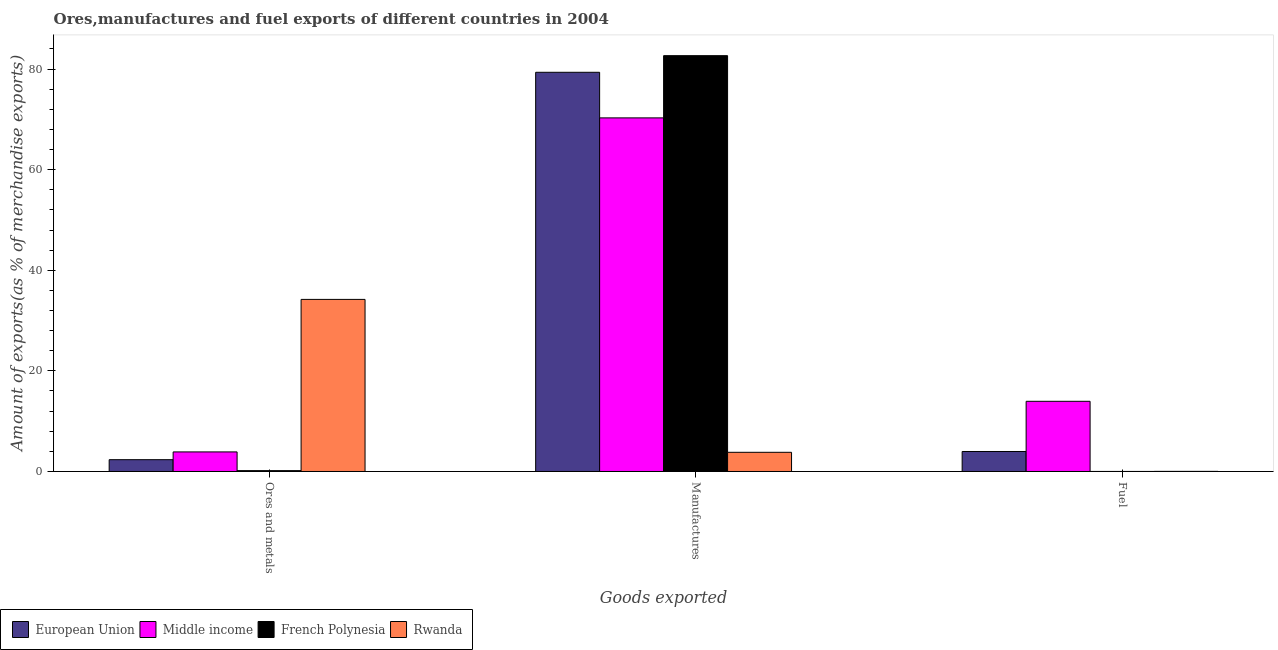How many different coloured bars are there?
Make the answer very short. 4. Are the number of bars per tick equal to the number of legend labels?
Provide a succinct answer. Yes. Are the number of bars on each tick of the X-axis equal?
Provide a succinct answer. Yes. How many bars are there on the 1st tick from the left?
Offer a very short reply. 4. How many bars are there on the 1st tick from the right?
Your answer should be compact. 4. What is the label of the 2nd group of bars from the left?
Offer a terse response. Manufactures. What is the percentage of ores and metals exports in European Union?
Your answer should be very brief. 2.35. Across all countries, what is the maximum percentage of ores and metals exports?
Give a very brief answer. 34.21. Across all countries, what is the minimum percentage of fuel exports?
Provide a short and direct response. 0. In which country was the percentage of manufactures exports maximum?
Provide a succinct answer. French Polynesia. In which country was the percentage of manufactures exports minimum?
Keep it short and to the point. Rwanda. What is the total percentage of fuel exports in the graph?
Provide a succinct answer. 17.95. What is the difference between the percentage of fuel exports in Rwanda and that in European Union?
Offer a terse response. -3.95. What is the difference between the percentage of fuel exports in Middle income and the percentage of manufactures exports in Rwanda?
Give a very brief answer. 10.14. What is the average percentage of manufactures exports per country?
Ensure brevity in your answer.  59.03. What is the difference between the percentage of manufactures exports and percentage of ores and metals exports in Rwanda?
Provide a succinct answer. -30.39. What is the ratio of the percentage of ores and metals exports in Rwanda to that in Middle income?
Provide a succinct answer. 8.8. Is the percentage of fuel exports in European Union less than that in Middle income?
Your answer should be very brief. Yes. Is the difference between the percentage of manufactures exports in Middle income and European Union greater than the difference between the percentage of ores and metals exports in Middle income and European Union?
Your answer should be compact. No. What is the difference between the highest and the second highest percentage of manufactures exports?
Your response must be concise. 3.31. What is the difference between the highest and the lowest percentage of manufactures exports?
Your response must be concise. 78.84. What does the 3rd bar from the right in Fuel represents?
Your response must be concise. Middle income. Is it the case that in every country, the sum of the percentage of ores and metals exports and percentage of manufactures exports is greater than the percentage of fuel exports?
Your response must be concise. Yes. How many bars are there?
Your answer should be compact. 12. What is the difference between two consecutive major ticks on the Y-axis?
Provide a succinct answer. 20. Are the values on the major ticks of Y-axis written in scientific E-notation?
Your answer should be very brief. No. Does the graph contain any zero values?
Offer a terse response. No. Does the graph contain grids?
Ensure brevity in your answer.  No. What is the title of the graph?
Ensure brevity in your answer.  Ores,manufactures and fuel exports of different countries in 2004. Does "Belgium" appear as one of the legend labels in the graph?
Give a very brief answer. No. What is the label or title of the X-axis?
Provide a succinct answer. Goods exported. What is the label or title of the Y-axis?
Keep it short and to the point. Amount of exports(as % of merchandise exports). What is the Amount of exports(as % of merchandise exports) of European Union in Ores and metals?
Provide a succinct answer. 2.35. What is the Amount of exports(as % of merchandise exports) of Middle income in Ores and metals?
Keep it short and to the point. 3.89. What is the Amount of exports(as % of merchandise exports) in French Polynesia in Ores and metals?
Provide a short and direct response. 0.17. What is the Amount of exports(as % of merchandise exports) in Rwanda in Ores and metals?
Provide a succinct answer. 34.21. What is the Amount of exports(as % of merchandise exports) in European Union in Manufactures?
Make the answer very short. 79.35. What is the Amount of exports(as % of merchandise exports) of Middle income in Manufactures?
Provide a short and direct response. 70.29. What is the Amount of exports(as % of merchandise exports) in French Polynesia in Manufactures?
Your response must be concise. 82.66. What is the Amount of exports(as % of merchandise exports) in Rwanda in Manufactures?
Provide a succinct answer. 3.81. What is the Amount of exports(as % of merchandise exports) of European Union in Fuel?
Your response must be concise. 3.97. What is the Amount of exports(as % of merchandise exports) in Middle income in Fuel?
Give a very brief answer. 13.95. What is the Amount of exports(as % of merchandise exports) in French Polynesia in Fuel?
Your answer should be compact. 0. What is the Amount of exports(as % of merchandise exports) in Rwanda in Fuel?
Offer a very short reply. 0.02. Across all Goods exported, what is the maximum Amount of exports(as % of merchandise exports) of European Union?
Keep it short and to the point. 79.35. Across all Goods exported, what is the maximum Amount of exports(as % of merchandise exports) in Middle income?
Provide a short and direct response. 70.29. Across all Goods exported, what is the maximum Amount of exports(as % of merchandise exports) of French Polynesia?
Your response must be concise. 82.66. Across all Goods exported, what is the maximum Amount of exports(as % of merchandise exports) in Rwanda?
Ensure brevity in your answer.  34.21. Across all Goods exported, what is the minimum Amount of exports(as % of merchandise exports) of European Union?
Your response must be concise. 2.35. Across all Goods exported, what is the minimum Amount of exports(as % of merchandise exports) of Middle income?
Your response must be concise. 3.89. Across all Goods exported, what is the minimum Amount of exports(as % of merchandise exports) in French Polynesia?
Keep it short and to the point. 0. Across all Goods exported, what is the minimum Amount of exports(as % of merchandise exports) of Rwanda?
Offer a terse response. 0.02. What is the total Amount of exports(as % of merchandise exports) of European Union in the graph?
Give a very brief answer. 85.67. What is the total Amount of exports(as % of merchandise exports) of Middle income in the graph?
Keep it short and to the point. 88.13. What is the total Amount of exports(as % of merchandise exports) in French Polynesia in the graph?
Offer a very short reply. 82.83. What is the total Amount of exports(as % of merchandise exports) in Rwanda in the graph?
Offer a terse response. 38.04. What is the difference between the Amount of exports(as % of merchandise exports) of European Union in Ores and metals and that in Manufactures?
Give a very brief answer. -77. What is the difference between the Amount of exports(as % of merchandise exports) of Middle income in Ores and metals and that in Manufactures?
Your response must be concise. -66.4. What is the difference between the Amount of exports(as % of merchandise exports) of French Polynesia in Ores and metals and that in Manufactures?
Your answer should be very brief. -82.49. What is the difference between the Amount of exports(as % of merchandise exports) of Rwanda in Ores and metals and that in Manufactures?
Offer a terse response. 30.39. What is the difference between the Amount of exports(as % of merchandise exports) of European Union in Ores and metals and that in Fuel?
Keep it short and to the point. -1.63. What is the difference between the Amount of exports(as % of merchandise exports) of Middle income in Ores and metals and that in Fuel?
Make the answer very short. -10.06. What is the difference between the Amount of exports(as % of merchandise exports) of French Polynesia in Ores and metals and that in Fuel?
Keep it short and to the point. 0.16. What is the difference between the Amount of exports(as % of merchandise exports) in Rwanda in Ores and metals and that in Fuel?
Provide a succinct answer. 34.18. What is the difference between the Amount of exports(as % of merchandise exports) in European Union in Manufactures and that in Fuel?
Your response must be concise. 75.38. What is the difference between the Amount of exports(as % of merchandise exports) in Middle income in Manufactures and that in Fuel?
Offer a terse response. 56.34. What is the difference between the Amount of exports(as % of merchandise exports) in French Polynesia in Manufactures and that in Fuel?
Provide a succinct answer. 82.65. What is the difference between the Amount of exports(as % of merchandise exports) of Rwanda in Manufactures and that in Fuel?
Your answer should be compact. 3.79. What is the difference between the Amount of exports(as % of merchandise exports) in European Union in Ores and metals and the Amount of exports(as % of merchandise exports) in Middle income in Manufactures?
Your answer should be very brief. -67.94. What is the difference between the Amount of exports(as % of merchandise exports) of European Union in Ores and metals and the Amount of exports(as % of merchandise exports) of French Polynesia in Manufactures?
Offer a very short reply. -80.31. What is the difference between the Amount of exports(as % of merchandise exports) of European Union in Ores and metals and the Amount of exports(as % of merchandise exports) of Rwanda in Manufactures?
Your answer should be compact. -1.47. What is the difference between the Amount of exports(as % of merchandise exports) in Middle income in Ores and metals and the Amount of exports(as % of merchandise exports) in French Polynesia in Manufactures?
Offer a terse response. -78.77. What is the difference between the Amount of exports(as % of merchandise exports) in Middle income in Ores and metals and the Amount of exports(as % of merchandise exports) in Rwanda in Manufactures?
Your answer should be very brief. 0.08. What is the difference between the Amount of exports(as % of merchandise exports) of French Polynesia in Ores and metals and the Amount of exports(as % of merchandise exports) of Rwanda in Manufactures?
Make the answer very short. -3.65. What is the difference between the Amount of exports(as % of merchandise exports) of European Union in Ores and metals and the Amount of exports(as % of merchandise exports) of Middle income in Fuel?
Your response must be concise. -11.6. What is the difference between the Amount of exports(as % of merchandise exports) of European Union in Ores and metals and the Amount of exports(as % of merchandise exports) of French Polynesia in Fuel?
Offer a terse response. 2.34. What is the difference between the Amount of exports(as % of merchandise exports) in European Union in Ores and metals and the Amount of exports(as % of merchandise exports) in Rwanda in Fuel?
Provide a short and direct response. 2.33. What is the difference between the Amount of exports(as % of merchandise exports) of Middle income in Ores and metals and the Amount of exports(as % of merchandise exports) of French Polynesia in Fuel?
Provide a short and direct response. 3.89. What is the difference between the Amount of exports(as % of merchandise exports) in Middle income in Ores and metals and the Amount of exports(as % of merchandise exports) in Rwanda in Fuel?
Provide a short and direct response. 3.87. What is the difference between the Amount of exports(as % of merchandise exports) in French Polynesia in Ores and metals and the Amount of exports(as % of merchandise exports) in Rwanda in Fuel?
Provide a short and direct response. 0.15. What is the difference between the Amount of exports(as % of merchandise exports) in European Union in Manufactures and the Amount of exports(as % of merchandise exports) in Middle income in Fuel?
Make the answer very short. 65.4. What is the difference between the Amount of exports(as % of merchandise exports) of European Union in Manufactures and the Amount of exports(as % of merchandise exports) of French Polynesia in Fuel?
Provide a succinct answer. 79.35. What is the difference between the Amount of exports(as % of merchandise exports) of European Union in Manufactures and the Amount of exports(as % of merchandise exports) of Rwanda in Fuel?
Make the answer very short. 79.33. What is the difference between the Amount of exports(as % of merchandise exports) in Middle income in Manufactures and the Amount of exports(as % of merchandise exports) in French Polynesia in Fuel?
Offer a terse response. 70.28. What is the difference between the Amount of exports(as % of merchandise exports) in Middle income in Manufactures and the Amount of exports(as % of merchandise exports) in Rwanda in Fuel?
Ensure brevity in your answer.  70.27. What is the difference between the Amount of exports(as % of merchandise exports) in French Polynesia in Manufactures and the Amount of exports(as % of merchandise exports) in Rwanda in Fuel?
Offer a very short reply. 82.63. What is the average Amount of exports(as % of merchandise exports) of European Union per Goods exported?
Give a very brief answer. 28.56. What is the average Amount of exports(as % of merchandise exports) of Middle income per Goods exported?
Provide a short and direct response. 29.38. What is the average Amount of exports(as % of merchandise exports) of French Polynesia per Goods exported?
Ensure brevity in your answer.  27.61. What is the average Amount of exports(as % of merchandise exports) of Rwanda per Goods exported?
Make the answer very short. 12.68. What is the difference between the Amount of exports(as % of merchandise exports) in European Union and Amount of exports(as % of merchandise exports) in Middle income in Ores and metals?
Provide a succinct answer. -1.54. What is the difference between the Amount of exports(as % of merchandise exports) of European Union and Amount of exports(as % of merchandise exports) of French Polynesia in Ores and metals?
Your answer should be compact. 2.18. What is the difference between the Amount of exports(as % of merchandise exports) in European Union and Amount of exports(as % of merchandise exports) in Rwanda in Ores and metals?
Your answer should be very brief. -31.86. What is the difference between the Amount of exports(as % of merchandise exports) of Middle income and Amount of exports(as % of merchandise exports) of French Polynesia in Ores and metals?
Ensure brevity in your answer.  3.72. What is the difference between the Amount of exports(as % of merchandise exports) of Middle income and Amount of exports(as % of merchandise exports) of Rwanda in Ores and metals?
Make the answer very short. -30.32. What is the difference between the Amount of exports(as % of merchandise exports) of French Polynesia and Amount of exports(as % of merchandise exports) of Rwanda in Ores and metals?
Provide a succinct answer. -34.04. What is the difference between the Amount of exports(as % of merchandise exports) in European Union and Amount of exports(as % of merchandise exports) in Middle income in Manufactures?
Ensure brevity in your answer.  9.06. What is the difference between the Amount of exports(as % of merchandise exports) of European Union and Amount of exports(as % of merchandise exports) of French Polynesia in Manufactures?
Provide a succinct answer. -3.31. What is the difference between the Amount of exports(as % of merchandise exports) in European Union and Amount of exports(as % of merchandise exports) in Rwanda in Manufactures?
Provide a succinct answer. 75.54. What is the difference between the Amount of exports(as % of merchandise exports) of Middle income and Amount of exports(as % of merchandise exports) of French Polynesia in Manufactures?
Offer a very short reply. -12.37. What is the difference between the Amount of exports(as % of merchandise exports) of Middle income and Amount of exports(as % of merchandise exports) of Rwanda in Manufactures?
Make the answer very short. 66.48. What is the difference between the Amount of exports(as % of merchandise exports) of French Polynesia and Amount of exports(as % of merchandise exports) of Rwanda in Manufactures?
Your answer should be very brief. 78.84. What is the difference between the Amount of exports(as % of merchandise exports) in European Union and Amount of exports(as % of merchandise exports) in Middle income in Fuel?
Offer a terse response. -9.98. What is the difference between the Amount of exports(as % of merchandise exports) in European Union and Amount of exports(as % of merchandise exports) in French Polynesia in Fuel?
Ensure brevity in your answer.  3.97. What is the difference between the Amount of exports(as % of merchandise exports) in European Union and Amount of exports(as % of merchandise exports) in Rwanda in Fuel?
Your response must be concise. 3.95. What is the difference between the Amount of exports(as % of merchandise exports) of Middle income and Amount of exports(as % of merchandise exports) of French Polynesia in Fuel?
Offer a very short reply. 13.95. What is the difference between the Amount of exports(as % of merchandise exports) of Middle income and Amount of exports(as % of merchandise exports) of Rwanda in Fuel?
Make the answer very short. 13.93. What is the difference between the Amount of exports(as % of merchandise exports) in French Polynesia and Amount of exports(as % of merchandise exports) in Rwanda in Fuel?
Your response must be concise. -0.02. What is the ratio of the Amount of exports(as % of merchandise exports) of European Union in Ores and metals to that in Manufactures?
Provide a succinct answer. 0.03. What is the ratio of the Amount of exports(as % of merchandise exports) in Middle income in Ores and metals to that in Manufactures?
Your answer should be compact. 0.06. What is the ratio of the Amount of exports(as % of merchandise exports) in French Polynesia in Ores and metals to that in Manufactures?
Your answer should be compact. 0. What is the ratio of the Amount of exports(as % of merchandise exports) of Rwanda in Ores and metals to that in Manufactures?
Give a very brief answer. 8.97. What is the ratio of the Amount of exports(as % of merchandise exports) of European Union in Ores and metals to that in Fuel?
Make the answer very short. 0.59. What is the ratio of the Amount of exports(as % of merchandise exports) in Middle income in Ores and metals to that in Fuel?
Keep it short and to the point. 0.28. What is the ratio of the Amount of exports(as % of merchandise exports) in French Polynesia in Ores and metals to that in Fuel?
Keep it short and to the point. 43.32. What is the ratio of the Amount of exports(as % of merchandise exports) in Rwanda in Ores and metals to that in Fuel?
Keep it short and to the point. 1651.57. What is the ratio of the Amount of exports(as % of merchandise exports) of European Union in Manufactures to that in Fuel?
Your answer should be compact. 19.97. What is the ratio of the Amount of exports(as % of merchandise exports) of Middle income in Manufactures to that in Fuel?
Offer a terse response. 5.04. What is the ratio of the Amount of exports(as % of merchandise exports) of French Polynesia in Manufactures to that in Fuel?
Give a very brief answer. 2.16e+04. What is the ratio of the Amount of exports(as % of merchandise exports) in Rwanda in Manufactures to that in Fuel?
Offer a terse response. 184.05. What is the difference between the highest and the second highest Amount of exports(as % of merchandise exports) of European Union?
Provide a short and direct response. 75.38. What is the difference between the highest and the second highest Amount of exports(as % of merchandise exports) in Middle income?
Give a very brief answer. 56.34. What is the difference between the highest and the second highest Amount of exports(as % of merchandise exports) in French Polynesia?
Give a very brief answer. 82.49. What is the difference between the highest and the second highest Amount of exports(as % of merchandise exports) in Rwanda?
Provide a succinct answer. 30.39. What is the difference between the highest and the lowest Amount of exports(as % of merchandise exports) of European Union?
Your answer should be compact. 77. What is the difference between the highest and the lowest Amount of exports(as % of merchandise exports) of Middle income?
Provide a short and direct response. 66.4. What is the difference between the highest and the lowest Amount of exports(as % of merchandise exports) in French Polynesia?
Your answer should be very brief. 82.65. What is the difference between the highest and the lowest Amount of exports(as % of merchandise exports) of Rwanda?
Keep it short and to the point. 34.18. 